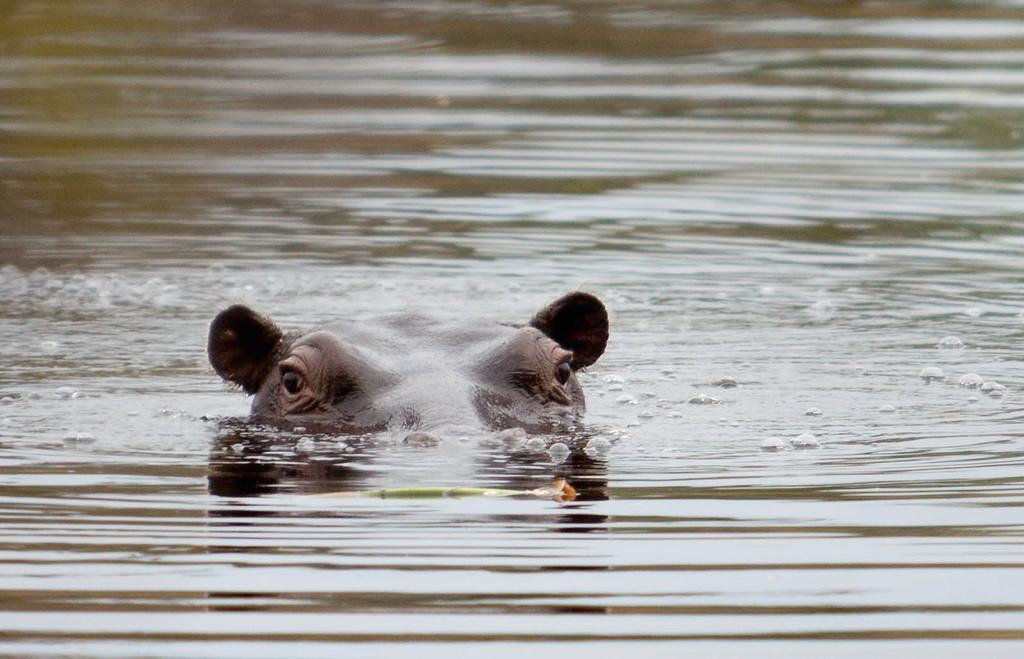Can you describe this image briefly? In the middle of this image, there is an animal having two ears and two eyes partially in the water. Beside this animal, there are water balloons on the surface of the water. And the background is blurred. 